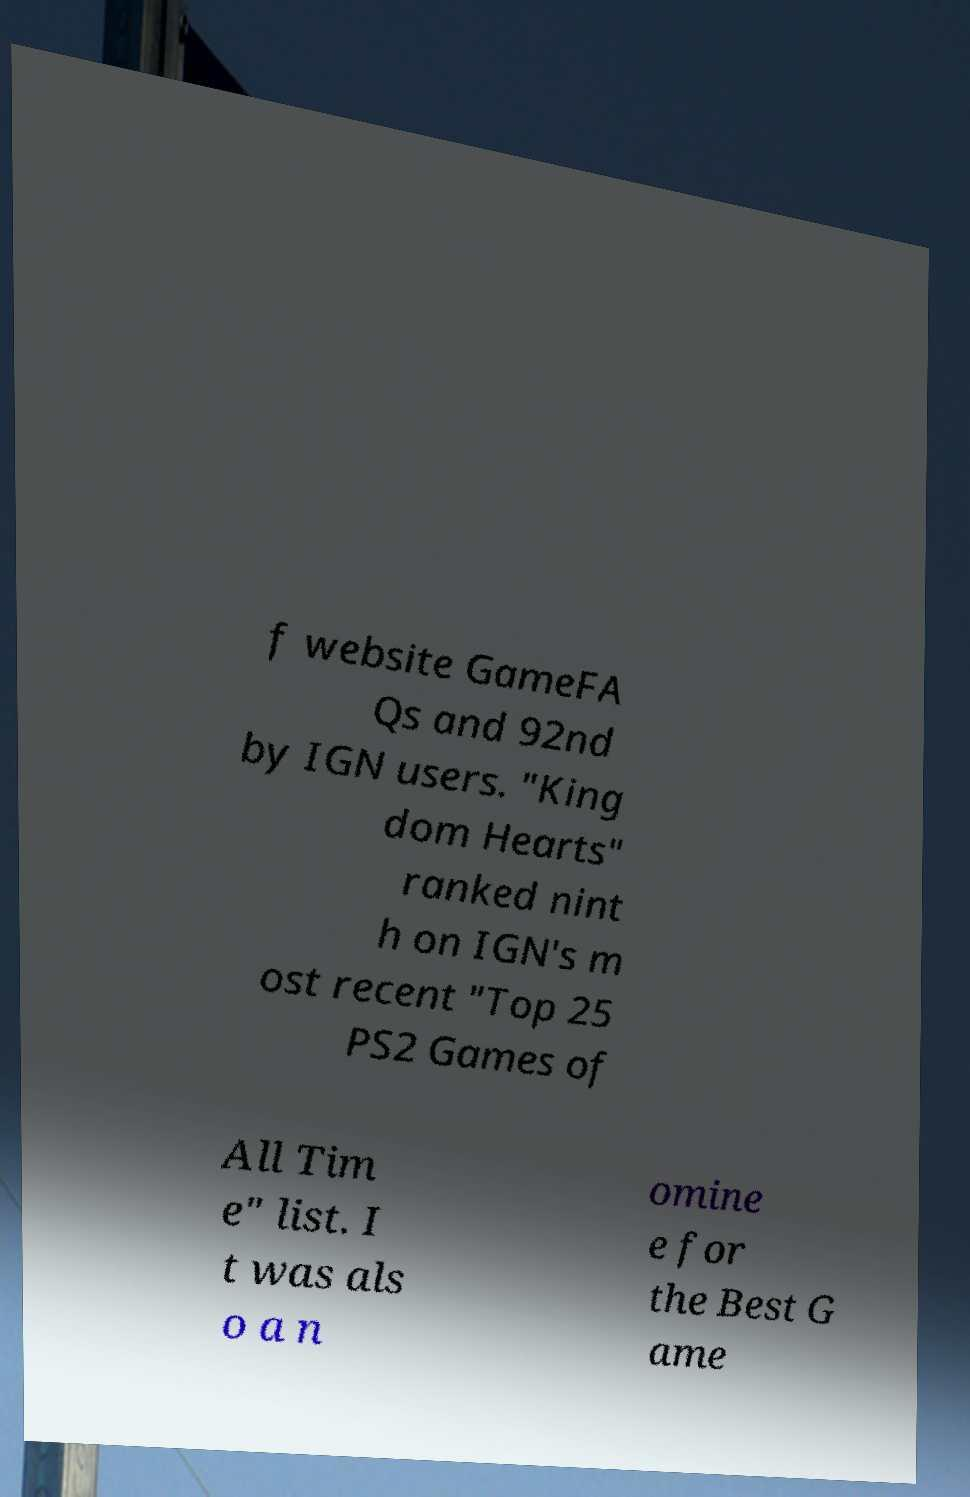What messages or text are displayed in this image? I need them in a readable, typed format. f website GameFA Qs and 92nd by IGN users. "King dom Hearts" ranked nint h on IGN's m ost recent "Top 25 PS2 Games of All Tim e" list. I t was als o a n omine e for the Best G ame 